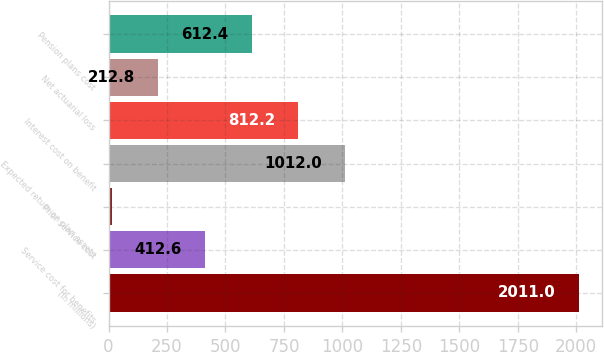Convert chart to OTSL. <chart><loc_0><loc_0><loc_500><loc_500><bar_chart><fcel>(In millions)<fcel>Service cost for benefits<fcel>Prior service cost<fcel>Expected return on plan assets<fcel>Interest cost on benefit<fcel>Net actuarial loss<fcel>Pension plans cost<nl><fcel>2011<fcel>412.6<fcel>13<fcel>1012<fcel>812.2<fcel>212.8<fcel>612.4<nl></chart> 